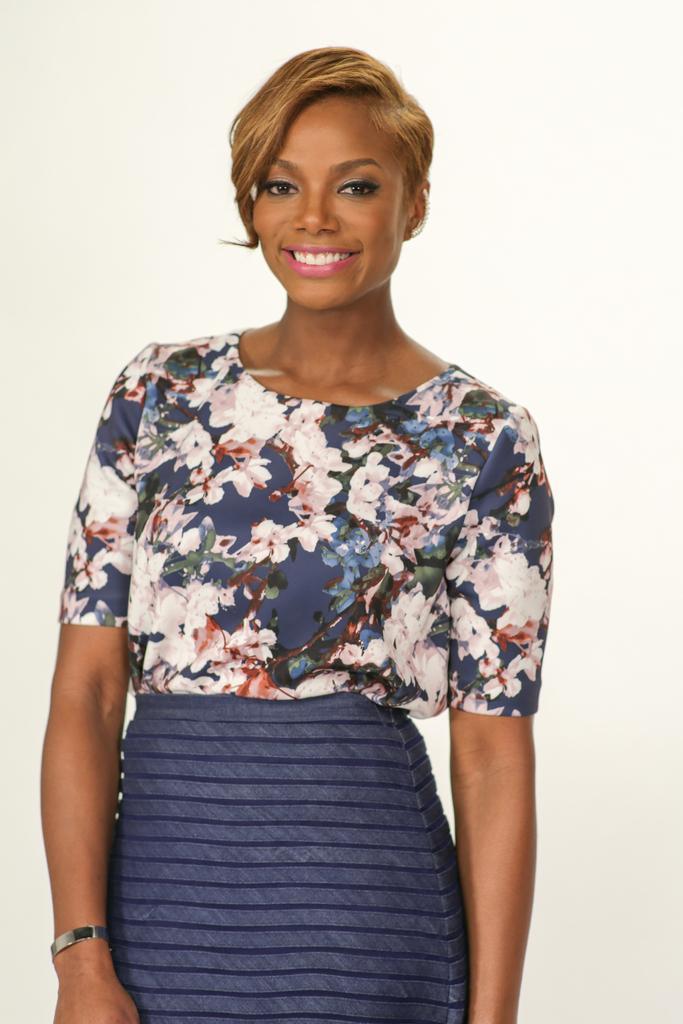Can you describe this image briefly? In this image I can see a woman is standing in the front and I can also see smile on her face. I can see she is wearing blue and pink colour dress. I can also see she is wearing a wrist bracelet. 